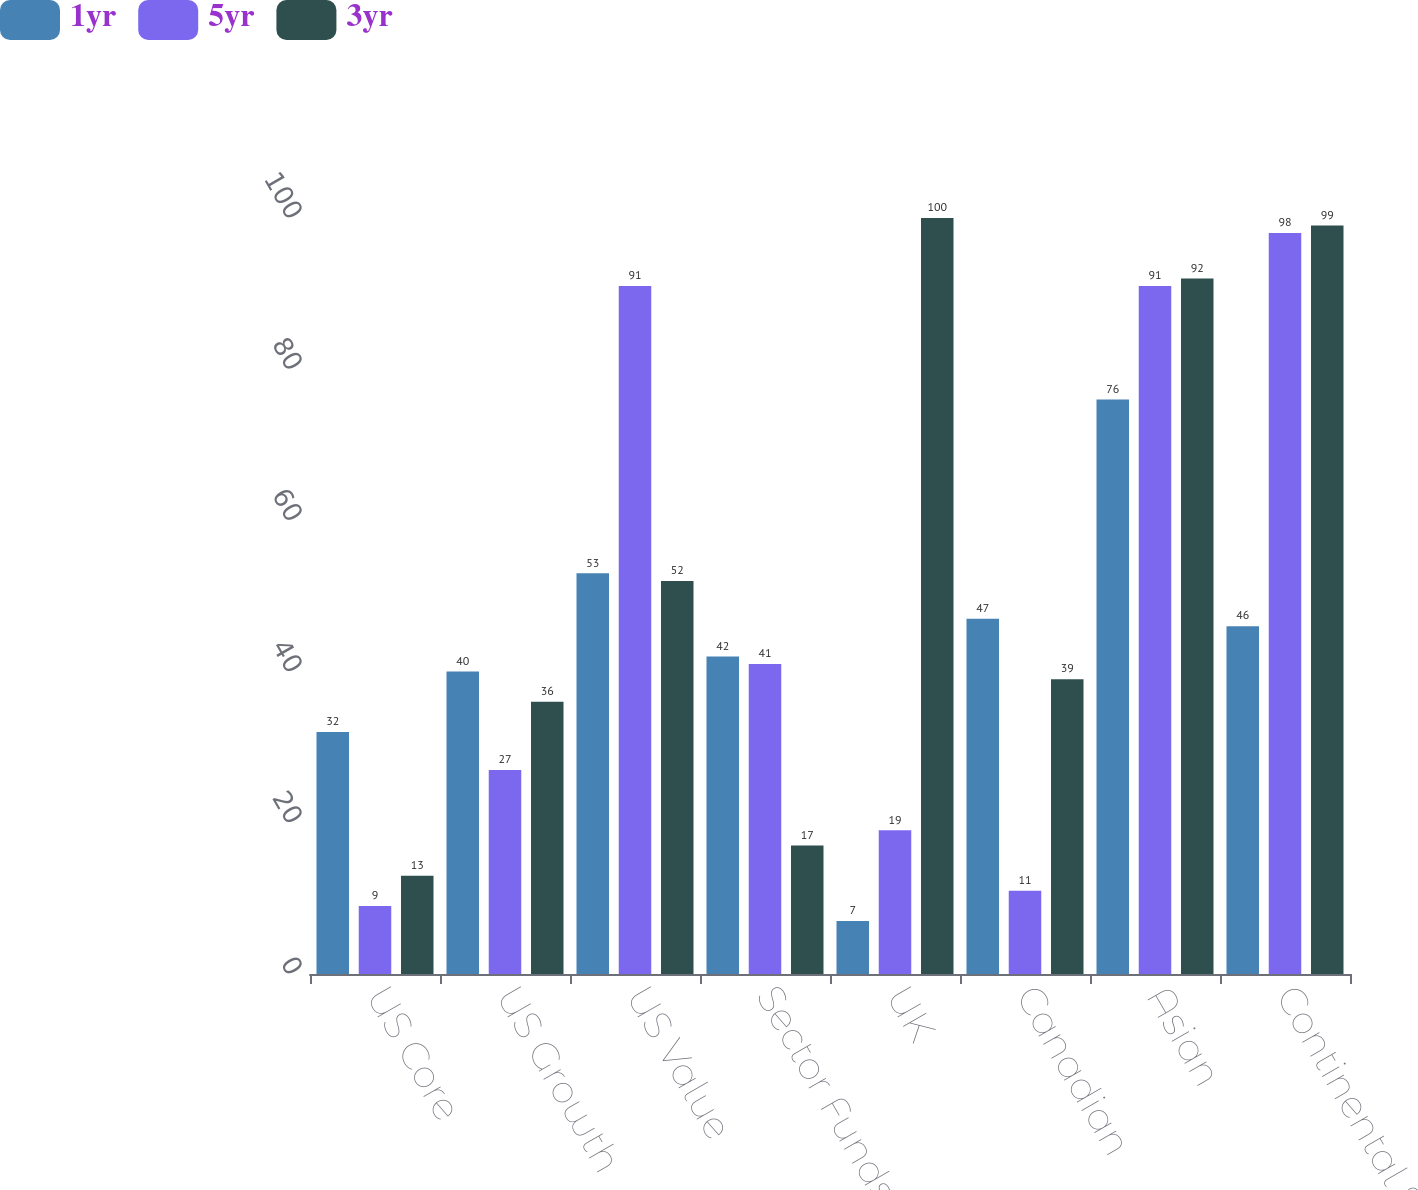<chart> <loc_0><loc_0><loc_500><loc_500><stacked_bar_chart><ecel><fcel>US Core<fcel>US Growth<fcel>US Value<fcel>Sector Funds<fcel>UK<fcel>Canadian<fcel>Asian<fcel>Continental European<nl><fcel>1yr<fcel>32<fcel>40<fcel>53<fcel>42<fcel>7<fcel>47<fcel>76<fcel>46<nl><fcel>5yr<fcel>9<fcel>27<fcel>91<fcel>41<fcel>19<fcel>11<fcel>91<fcel>98<nl><fcel>3yr<fcel>13<fcel>36<fcel>52<fcel>17<fcel>100<fcel>39<fcel>92<fcel>99<nl></chart> 